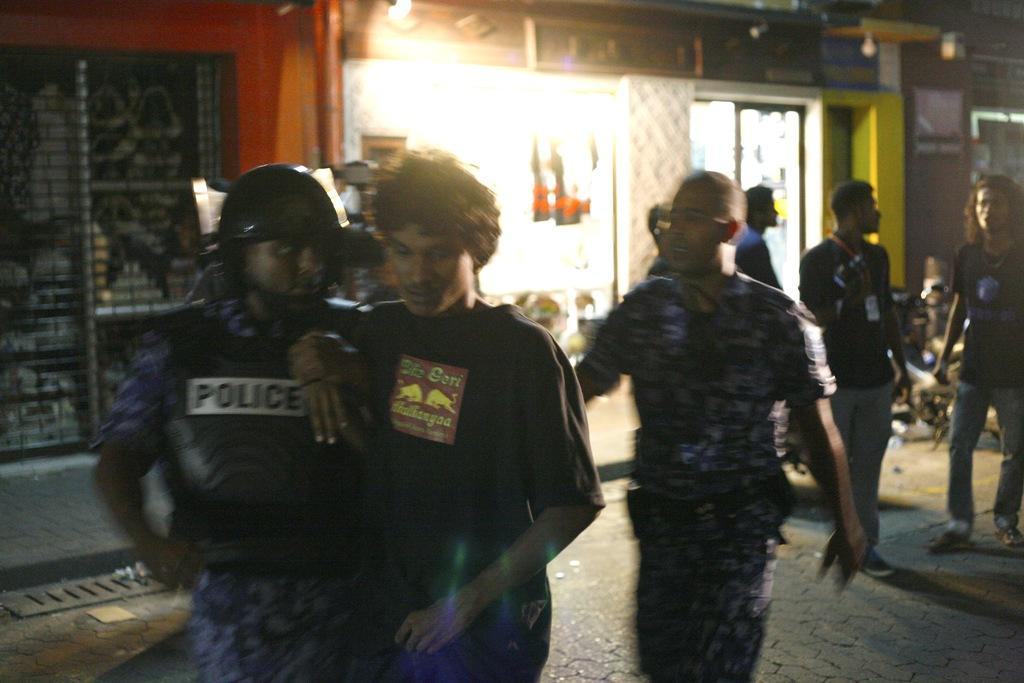Could you give a brief overview of what you see in this image? In this image we can see some people among them some are standing and some are walking in a street. In the background, we can see a building and we can see a motorcycle. 